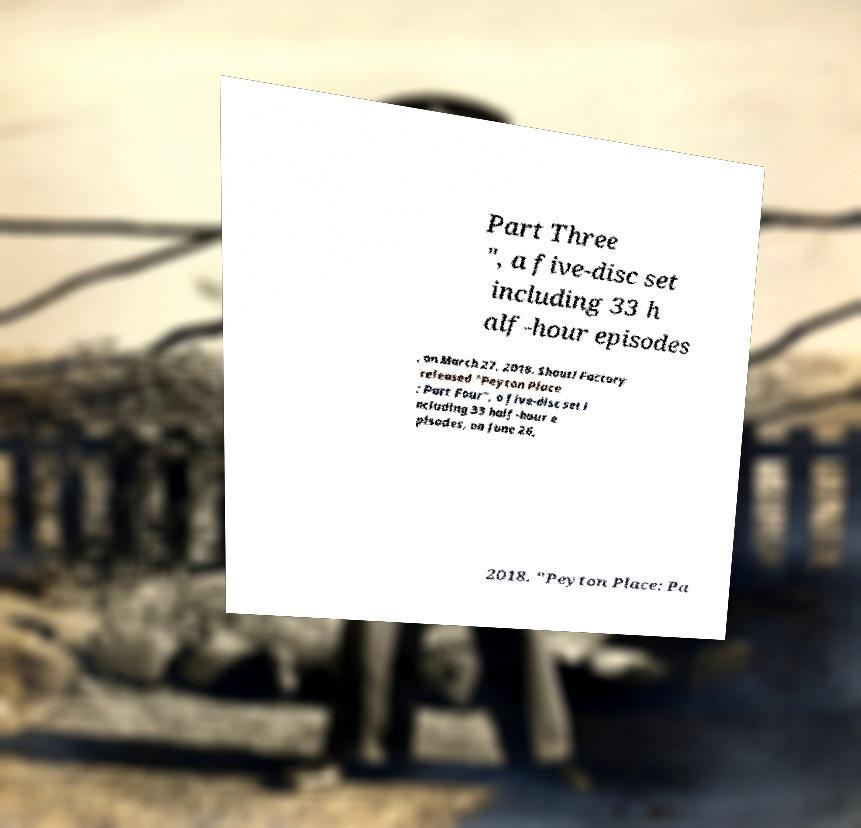Can you accurately transcribe the text from the provided image for me? Part Three ", a five-disc set including 33 h alf-hour episodes , on March 27, 2018. Shout! Factory released "Peyton Place : Part Four", a five-disc set i ncluding 33 half-hour e pisodes, on June 26, 2018. "Peyton Place: Pa 